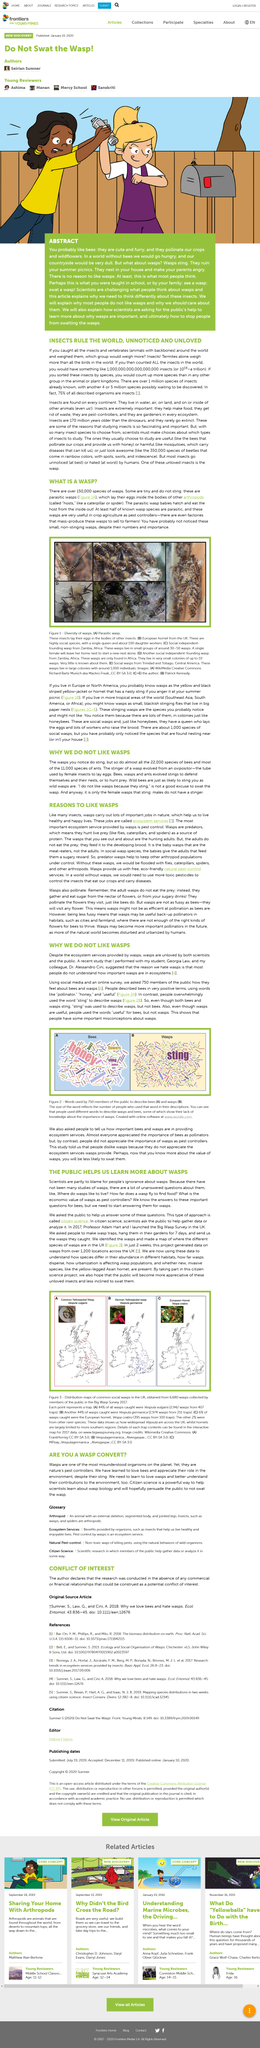Highlight a few significant elements in this photo. What is this article about? It is about wasps. The picture depicts a parasitic wasp, which is a type of wasp known for its parasitic lifestyle. Wääs are unloved bï the pïöïçé? Yes, wääs are unloved... The person who took the picture of B is named Patrick Kennedy. In the future, it is likely that wasps will become an increasingly important pollinator. 